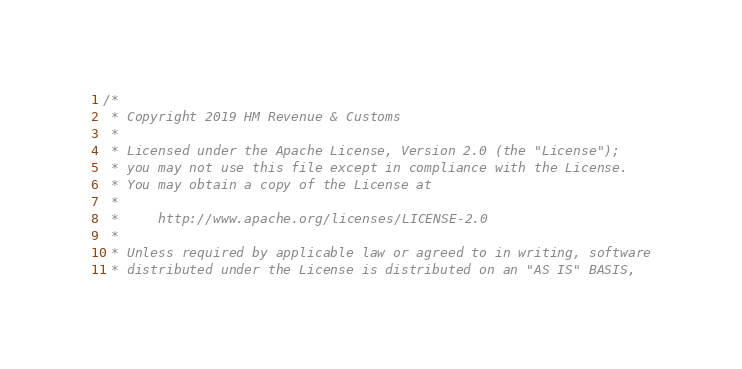Convert code to text. <code><loc_0><loc_0><loc_500><loc_500><_Scala_>/*
 * Copyright 2019 HM Revenue & Customs
 *
 * Licensed under the Apache License, Version 2.0 (the "License");
 * you may not use this file except in compliance with the License.
 * You may obtain a copy of the License at
 *
 *     http://www.apache.org/licenses/LICENSE-2.0
 *
 * Unless required by applicable law or agreed to in writing, software
 * distributed under the License is distributed on an "AS IS" BASIS,</code> 